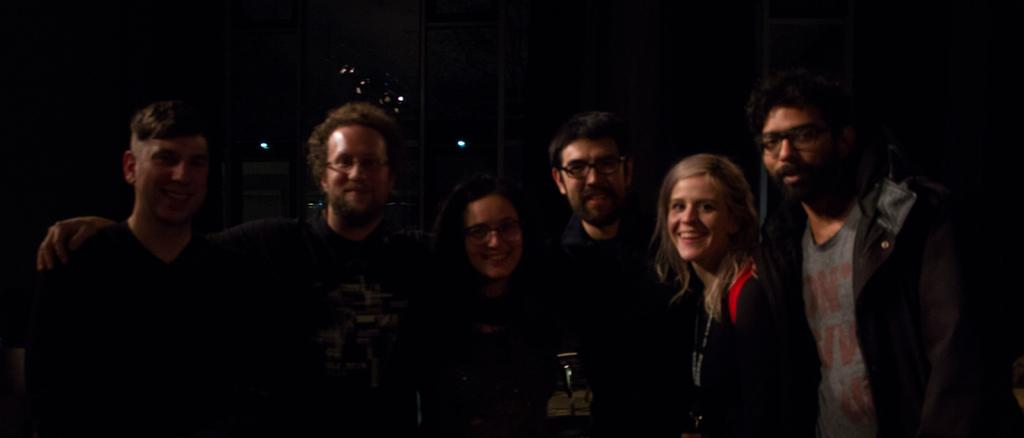How many people are in the image? There are three people in the image: two men on the left side and a woman in the middle. What are the expressions of the people in the image? All three people are smiling. Can you describe the woman on the right side of the image? The woman on the right side is wearing a coat and smiling. What type of wine is being served on the island in the image? There is no wine or island present in the image; it features three people smiling. 